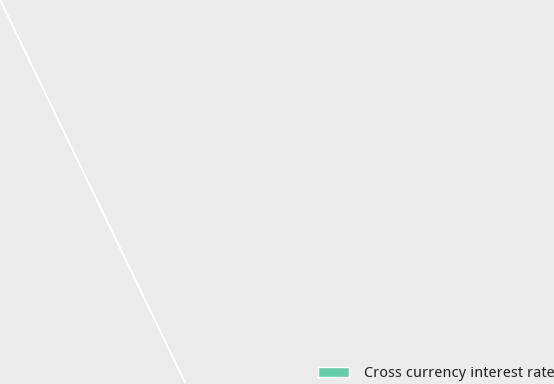<chart> <loc_0><loc_0><loc_500><loc_500><pie_chart><fcel>Cross currency interest rate<nl><fcel>100.0%<nl></chart> 